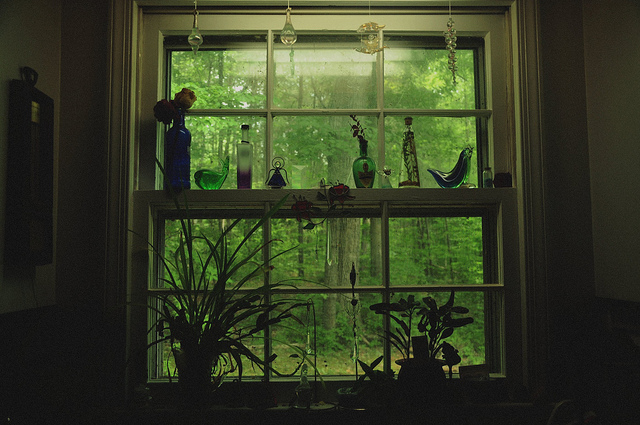If these vases could talk, what kind of conversations might they have? The tall blue vase might start by reminiscing about its arrival, transported carefully from a distant land. The bird-shaped vase would chip in, recounting the time it witnessed a real bird pecking curiously at the window. Meanwhile, the shorter vases would chat about overhearing the daily conversations and secrets shared in the room, marveling at the tales of joy and sorrow. The green vases, reflecting the lush outdoor scenery, would likely discuss the changing seasons and the beautiful view they are fortunate to enjoy every day. Together, their conversations would weave a tapestry of memories, each one contributing to the rich history embodied in this serene, cozy window corner. In a more imaginative twist, the vases might even debate the merits of their shapes and colors, or plan adventurous escapes to explore the forest just outside, ever curious about the world beyond the glass. Perhaps they'd even form a little vase club, meeting under the moonlight to share the day's observations and fantasies. 